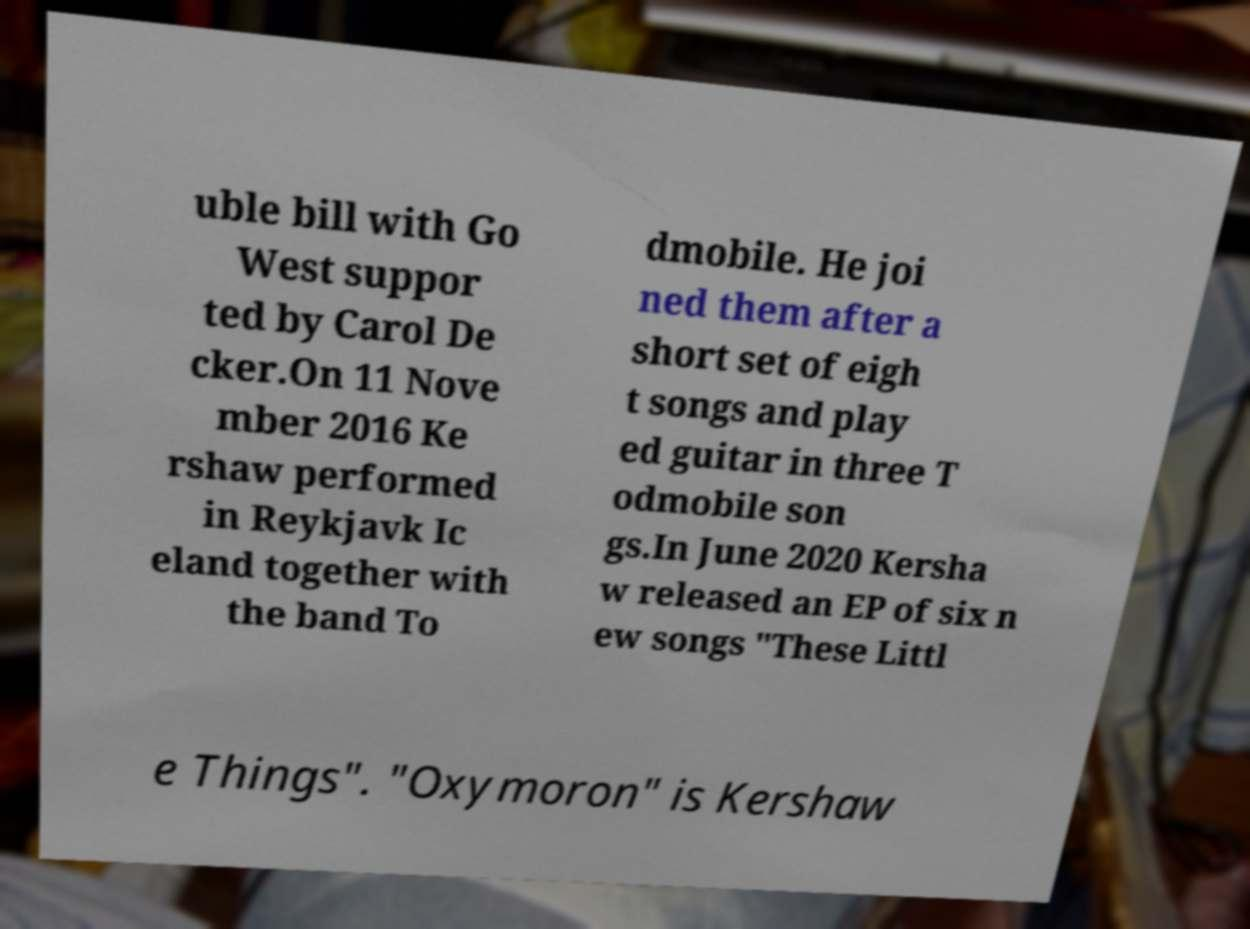For documentation purposes, I need the text within this image transcribed. Could you provide that? uble bill with Go West suppor ted by Carol De cker.On 11 Nove mber 2016 Ke rshaw performed in Reykjavk Ic eland together with the band To dmobile. He joi ned them after a short set of eigh t songs and play ed guitar in three T odmobile son gs.In June 2020 Kersha w released an EP of six n ew songs "These Littl e Things". "Oxymoron" is Kershaw 